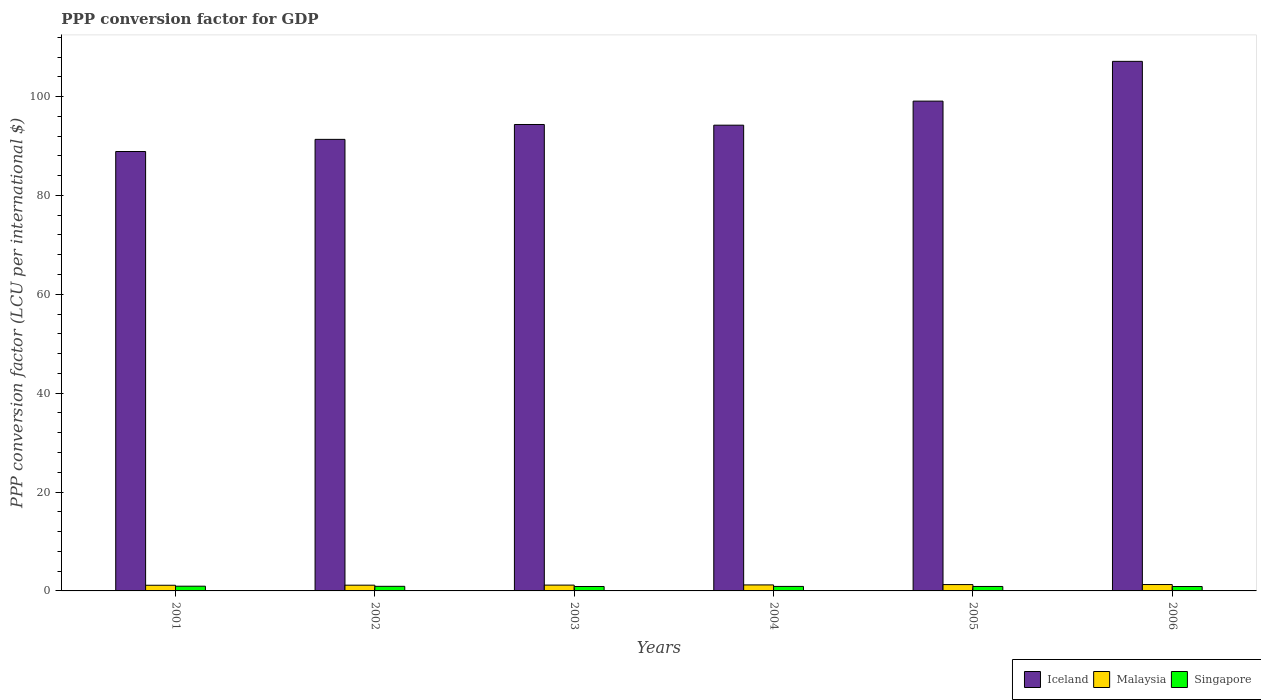How many different coloured bars are there?
Your answer should be very brief. 3. How many groups of bars are there?
Provide a succinct answer. 6. Are the number of bars per tick equal to the number of legend labels?
Ensure brevity in your answer.  Yes. How many bars are there on the 1st tick from the left?
Provide a short and direct response. 3. How many bars are there on the 3rd tick from the right?
Offer a terse response. 3. What is the label of the 6th group of bars from the left?
Make the answer very short. 2006. In how many cases, is the number of bars for a given year not equal to the number of legend labels?
Ensure brevity in your answer.  0. What is the PPP conversion factor for GDP in Iceland in 2002?
Ensure brevity in your answer.  91.34. Across all years, what is the maximum PPP conversion factor for GDP in Malaysia?
Your answer should be very brief. 1.29. Across all years, what is the minimum PPP conversion factor for GDP in Singapore?
Your response must be concise. 0.89. In which year was the PPP conversion factor for GDP in Iceland minimum?
Give a very brief answer. 2001. What is the total PPP conversion factor for GDP in Iceland in the graph?
Provide a short and direct response. 574.99. What is the difference between the PPP conversion factor for GDP in Malaysia in 2001 and that in 2006?
Your response must be concise. -0.15. What is the difference between the PPP conversion factor for GDP in Singapore in 2005 and the PPP conversion factor for GDP in Iceland in 2004?
Give a very brief answer. -93.31. What is the average PPP conversion factor for GDP in Iceland per year?
Make the answer very short. 95.83. In the year 2001, what is the difference between the PPP conversion factor for GDP in Malaysia and PPP conversion factor for GDP in Iceland?
Your response must be concise. -87.74. What is the ratio of the PPP conversion factor for GDP in Iceland in 2003 to that in 2005?
Your answer should be compact. 0.95. Is the difference between the PPP conversion factor for GDP in Malaysia in 2005 and 2006 greater than the difference between the PPP conversion factor for GDP in Iceland in 2005 and 2006?
Offer a very short reply. Yes. What is the difference between the highest and the second highest PPP conversion factor for GDP in Iceland?
Keep it short and to the point. 8.04. What is the difference between the highest and the lowest PPP conversion factor for GDP in Singapore?
Provide a short and direct response. 0.07. In how many years, is the PPP conversion factor for GDP in Iceland greater than the average PPP conversion factor for GDP in Iceland taken over all years?
Make the answer very short. 2. Is the sum of the PPP conversion factor for GDP in Malaysia in 2004 and 2006 greater than the maximum PPP conversion factor for GDP in Singapore across all years?
Make the answer very short. Yes. What does the 2nd bar from the left in 2003 represents?
Provide a short and direct response. Malaysia. What does the 3rd bar from the right in 2003 represents?
Keep it short and to the point. Iceland. Does the graph contain any zero values?
Offer a terse response. No. Does the graph contain grids?
Ensure brevity in your answer.  No. Where does the legend appear in the graph?
Offer a terse response. Bottom right. What is the title of the graph?
Make the answer very short. PPP conversion factor for GDP. What is the label or title of the Y-axis?
Make the answer very short. PPP conversion factor (LCU per international $). What is the PPP conversion factor (LCU per international $) of Iceland in 2001?
Offer a very short reply. 88.89. What is the PPP conversion factor (LCU per international $) in Malaysia in 2001?
Your answer should be very brief. 1.14. What is the PPP conversion factor (LCU per international $) of Singapore in 2001?
Your answer should be compact. 0.96. What is the PPP conversion factor (LCU per international $) in Iceland in 2002?
Make the answer very short. 91.34. What is the PPP conversion factor (LCU per international $) of Malaysia in 2002?
Offer a very short reply. 1.16. What is the PPP conversion factor (LCU per international $) of Singapore in 2002?
Your response must be concise. 0.93. What is the PPP conversion factor (LCU per international $) of Iceland in 2003?
Offer a terse response. 94.35. What is the PPP conversion factor (LCU per international $) in Malaysia in 2003?
Provide a short and direct response. 1.18. What is the PPP conversion factor (LCU per international $) in Singapore in 2003?
Give a very brief answer. 0.9. What is the PPP conversion factor (LCU per international $) in Iceland in 2004?
Offer a terse response. 94.21. What is the PPP conversion factor (LCU per international $) of Malaysia in 2004?
Make the answer very short. 1.21. What is the PPP conversion factor (LCU per international $) of Singapore in 2004?
Ensure brevity in your answer.  0.91. What is the PPP conversion factor (LCU per international $) in Iceland in 2005?
Provide a succinct answer. 99.08. What is the PPP conversion factor (LCU per international $) in Malaysia in 2005?
Keep it short and to the point. 1.28. What is the PPP conversion factor (LCU per international $) in Singapore in 2005?
Your answer should be compact. 0.9. What is the PPP conversion factor (LCU per international $) of Iceland in 2006?
Offer a terse response. 107.12. What is the PPP conversion factor (LCU per international $) in Malaysia in 2006?
Provide a succinct answer. 1.29. What is the PPP conversion factor (LCU per international $) of Singapore in 2006?
Make the answer very short. 0.89. Across all years, what is the maximum PPP conversion factor (LCU per international $) in Iceland?
Your answer should be compact. 107.12. Across all years, what is the maximum PPP conversion factor (LCU per international $) in Malaysia?
Your response must be concise. 1.29. Across all years, what is the maximum PPP conversion factor (LCU per international $) in Singapore?
Provide a succinct answer. 0.96. Across all years, what is the minimum PPP conversion factor (LCU per international $) of Iceland?
Your answer should be compact. 88.89. Across all years, what is the minimum PPP conversion factor (LCU per international $) of Malaysia?
Your answer should be very brief. 1.14. Across all years, what is the minimum PPP conversion factor (LCU per international $) of Singapore?
Offer a terse response. 0.89. What is the total PPP conversion factor (LCU per international $) in Iceland in the graph?
Give a very brief answer. 574.99. What is the total PPP conversion factor (LCU per international $) of Malaysia in the graph?
Provide a short and direct response. 7.27. What is the total PPP conversion factor (LCU per international $) of Singapore in the graph?
Ensure brevity in your answer.  5.49. What is the difference between the PPP conversion factor (LCU per international $) in Iceland in 2001 and that in 2002?
Keep it short and to the point. -2.46. What is the difference between the PPP conversion factor (LCU per international $) in Malaysia in 2001 and that in 2002?
Provide a succinct answer. -0.02. What is the difference between the PPP conversion factor (LCU per international $) in Singapore in 2001 and that in 2002?
Offer a very short reply. 0.03. What is the difference between the PPP conversion factor (LCU per international $) in Iceland in 2001 and that in 2003?
Ensure brevity in your answer.  -5.47. What is the difference between the PPP conversion factor (LCU per international $) of Malaysia in 2001 and that in 2003?
Provide a short and direct response. -0.03. What is the difference between the PPP conversion factor (LCU per international $) in Iceland in 2001 and that in 2004?
Your response must be concise. -5.33. What is the difference between the PPP conversion factor (LCU per international $) in Malaysia in 2001 and that in 2004?
Ensure brevity in your answer.  -0.07. What is the difference between the PPP conversion factor (LCU per international $) of Singapore in 2001 and that in 2004?
Offer a terse response. 0.05. What is the difference between the PPP conversion factor (LCU per international $) in Iceland in 2001 and that in 2005?
Give a very brief answer. -10.19. What is the difference between the PPP conversion factor (LCU per international $) of Malaysia in 2001 and that in 2005?
Your answer should be very brief. -0.14. What is the difference between the PPP conversion factor (LCU per international $) in Singapore in 2001 and that in 2005?
Give a very brief answer. 0.06. What is the difference between the PPP conversion factor (LCU per international $) in Iceland in 2001 and that in 2006?
Your response must be concise. -18.24. What is the difference between the PPP conversion factor (LCU per international $) in Malaysia in 2001 and that in 2006?
Provide a short and direct response. -0.15. What is the difference between the PPP conversion factor (LCU per international $) in Singapore in 2001 and that in 2006?
Provide a short and direct response. 0.07. What is the difference between the PPP conversion factor (LCU per international $) in Iceland in 2002 and that in 2003?
Your answer should be compact. -3.01. What is the difference between the PPP conversion factor (LCU per international $) of Malaysia in 2002 and that in 2003?
Offer a terse response. -0.01. What is the difference between the PPP conversion factor (LCU per international $) of Singapore in 2002 and that in 2003?
Offer a terse response. 0.03. What is the difference between the PPP conversion factor (LCU per international $) in Iceland in 2002 and that in 2004?
Your answer should be very brief. -2.87. What is the difference between the PPP conversion factor (LCU per international $) of Malaysia in 2002 and that in 2004?
Provide a succinct answer. -0.05. What is the difference between the PPP conversion factor (LCU per international $) of Singapore in 2002 and that in 2004?
Your response must be concise. 0.02. What is the difference between the PPP conversion factor (LCU per international $) of Iceland in 2002 and that in 2005?
Your answer should be compact. -7.74. What is the difference between the PPP conversion factor (LCU per international $) in Malaysia in 2002 and that in 2005?
Ensure brevity in your answer.  -0.12. What is the difference between the PPP conversion factor (LCU per international $) in Singapore in 2002 and that in 2005?
Provide a short and direct response. 0.03. What is the difference between the PPP conversion factor (LCU per international $) in Iceland in 2002 and that in 2006?
Your response must be concise. -15.78. What is the difference between the PPP conversion factor (LCU per international $) in Malaysia in 2002 and that in 2006?
Offer a very short reply. -0.13. What is the difference between the PPP conversion factor (LCU per international $) in Singapore in 2002 and that in 2006?
Ensure brevity in your answer.  0.04. What is the difference between the PPP conversion factor (LCU per international $) of Iceland in 2003 and that in 2004?
Ensure brevity in your answer.  0.14. What is the difference between the PPP conversion factor (LCU per international $) of Malaysia in 2003 and that in 2004?
Ensure brevity in your answer.  -0.04. What is the difference between the PPP conversion factor (LCU per international $) in Singapore in 2003 and that in 2004?
Your answer should be compact. -0.01. What is the difference between the PPP conversion factor (LCU per international $) of Iceland in 2003 and that in 2005?
Keep it short and to the point. -4.73. What is the difference between the PPP conversion factor (LCU per international $) in Malaysia in 2003 and that in 2005?
Your answer should be very brief. -0.1. What is the difference between the PPP conversion factor (LCU per international $) in Singapore in 2003 and that in 2005?
Your answer should be compact. -0. What is the difference between the PPP conversion factor (LCU per international $) of Iceland in 2003 and that in 2006?
Provide a succinct answer. -12.77. What is the difference between the PPP conversion factor (LCU per international $) in Malaysia in 2003 and that in 2006?
Give a very brief answer. -0.12. What is the difference between the PPP conversion factor (LCU per international $) of Singapore in 2003 and that in 2006?
Offer a very short reply. 0.01. What is the difference between the PPP conversion factor (LCU per international $) in Iceland in 2004 and that in 2005?
Offer a very short reply. -4.87. What is the difference between the PPP conversion factor (LCU per international $) of Malaysia in 2004 and that in 2005?
Your answer should be very brief. -0.07. What is the difference between the PPP conversion factor (LCU per international $) in Singapore in 2004 and that in 2005?
Your answer should be very brief. 0.01. What is the difference between the PPP conversion factor (LCU per international $) in Iceland in 2004 and that in 2006?
Offer a terse response. -12.91. What is the difference between the PPP conversion factor (LCU per international $) in Malaysia in 2004 and that in 2006?
Ensure brevity in your answer.  -0.08. What is the difference between the PPP conversion factor (LCU per international $) of Singapore in 2004 and that in 2006?
Offer a terse response. 0.02. What is the difference between the PPP conversion factor (LCU per international $) of Iceland in 2005 and that in 2006?
Provide a short and direct response. -8.04. What is the difference between the PPP conversion factor (LCU per international $) of Malaysia in 2005 and that in 2006?
Your answer should be very brief. -0.01. What is the difference between the PPP conversion factor (LCU per international $) of Singapore in 2005 and that in 2006?
Provide a succinct answer. 0.01. What is the difference between the PPP conversion factor (LCU per international $) of Iceland in 2001 and the PPP conversion factor (LCU per international $) of Malaysia in 2002?
Give a very brief answer. 87.72. What is the difference between the PPP conversion factor (LCU per international $) in Iceland in 2001 and the PPP conversion factor (LCU per international $) in Singapore in 2002?
Your answer should be compact. 87.95. What is the difference between the PPP conversion factor (LCU per international $) in Malaysia in 2001 and the PPP conversion factor (LCU per international $) in Singapore in 2002?
Provide a short and direct response. 0.21. What is the difference between the PPP conversion factor (LCU per international $) in Iceland in 2001 and the PPP conversion factor (LCU per international $) in Malaysia in 2003?
Your answer should be very brief. 87.71. What is the difference between the PPP conversion factor (LCU per international $) of Iceland in 2001 and the PPP conversion factor (LCU per international $) of Singapore in 2003?
Give a very brief answer. 87.99. What is the difference between the PPP conversion factor (LCU per international $) in Malaysia in 2001 and the PPP conversion factor (LCU per international $) in Singapore in 2003?
Make the answer very short. 0.25. What is the difference between the PPP conversion factor (LCU per international $) in Iceland in 2001 and the PPP conversion factor (LCU per international $) in Malaysia in 2004?
Provide a short and direct response. 87.67. What is the difference between the PPP conversion factor (LCU per international $) in Iceland in 2001 and the PPP conversion factor (LCU per international $) in Singapore in 2004?
Provide a short and direct response. 87.97. What is the difference between the PPP conversion factor (LCU per international $) in Malaysia in 2001 and the PPP conversion factor (LCU per international $) in Singapore in 2004?
Provide a short and direct response. 0.23. What is the difference between the PPP conversion factor (LCU per international $) of Iceland in 2001 and the PPP conversion factor (LCU per international $) of Malaysia in 2005?
Offer a terse response. 87.6. What is the difference between the PPP conversion factor (LCU per international $) of Iceland in 2001 and the PPP conversion factor (LCU per international $) of Singapore in 2005?
Offer a terse response. 87.98. What is the difference between the PPP conversion factor (LCU per international $) of Malaysia in 2001 and the PPP conversion factor (LCU per international $) of Singapore in 2005?
Ensure brevity in your answer.  0.24. What is the difference between the PPP conversion factor (LCU per international $) of Iceland in 2001 and the PPP conversion factor (LCU per international $) of Malaysia in 2006?
Your answer should be very brief. 87.59. What is the difference between the PPP conversion factor (LCU per international $) of Iceland in 2001 and the PPP conversion factor (LCU per international $) of Singapore in 2006?
Keep it short and to the point. 88. What is the difference between the PPP conversion factor (LCU per international $) in Malaysia in 2001 and the PPP conversion factor (LCU per international $) in Singapore in 2006?
Offer a terse response. 0.25. What is the difference between the PPP conversion factor (LCU per international $) of Iceland in 2002 and the PPP conversion factor (LCU per international $) of Malaysia in 2003?
Give a very brief answer. 90.16. What is the difference between the PPP conversion factor (LCU per international $) of Iceland in 2002 and the PPP conversion factor (LCU per international $) of Singapore in 2003?
Keep it short and to the point. 90.44. What is the difference between the PPP conversion factor (LCU per international $) of Malaysia in 2002 and the PPP conversion factor (LCU per international $) of Singapore in 2003?
Your answer should be very brief. 0.26. What is the difference between the PPP conversion factor (LCU per international $) of Iceland in 2002 and the PPP conversion factor (LCU per international $) of Malaysia in 2004?
Give a very brief answer. 90.13. What is the difference between the PPP conversion factor (LCU per international $) of Iceland in 2002 and the PPP conversion factor (LCU per international $) of Singapore in 2004?
Offer a terse response. 90.43. What is the difference between the PPP conversion factor (LCU per international $) of Malaysia in 2002 and the PPP conversion factor (LCU per international $) of Singapore in 2004?
Give a very brief answer. 0.25. What is the difference between the PPP conversion factor (LCU per international $) of Iceland in 2002 and the PPP conversion factor (LCU per international $) of Malaysia in 2005?
Provide a short and direct response. 90.06. What is the difference between the PPP conversion factor (LCU per international $) of Iceland in 2002 and the PPP conversion factor (LCU per international $) of Singapore in 2005?
Provide a succinct answer. 90.44. What is the difference between the PPP conversion factor (LCU per international $) in Malaysia in 2002 and the PPP conversion factor (LCU per international $) in Singapore in 2005?
Ensure brevity in your answer.  0.26. What is the difference between the PPP conversion factor (LCU per international $) of Iceland in 2002 and the PPP conversion factor (LCU per international $) of Malaysia in 2006?
Make the answer very short. 90.05. What is the difference between the PPP conversion factor (LCU per international $) of Iceland in 2002 and the PPP conversion factor (LCU per international $) of Singapore in 2006?
Provide a succinct answer. 90.45. What is the difference between the PPP conversion factor (LCU per international $) of Malaysia in 2002 and the PPP conversion factor (LCU per international $) of Singapore in 2006?
Make the answer very short. 0.27. What is the difference between the PPP conversion factor (LCU per international $) in Iceland in 2003 and the PPP conversion factor (LCU per international $) in Malaysia in 2004?
Give a very brief answer. 93.14. What is the difference between the PPP conversion factor (LCU per international $) of Iceland in 2003 and the PPP conversion factor (LCU per international $) of Singapore in 2004?
Give a very brief answer. 93.44. What is the difference between the PPP conversion factor (LCU per international $) in Malaysia in 2003 and the PPP conversion factor (LCU per international $) in Singapore in 2004?
Offer a very short reply. 0.27. What is the difference between the PPP conversion factor (LCU per international $) of Iceland in 2003 and the PPP conversion factor (LCU per international $) of Malaysia in 2005?
Provide a succinct answer. 93.07. What is the difference between the PPP conversion factor (LCU per international $) of Iceland in 2003 and the PPP conversion factor (LCU per international $) of Singapore in 2005?
Keep it short and to the point. 93.45. What is the difference between the PPP conversion factor (LCU per international $) of Malaysia in 2003 and the PPP conversion factor (LCU per international $) of Singapore in 2005?
Provide a short and direct response. 0.28. What is the difference between the PPP conversion factor (LCU per international $) of Iceland in 2003 and the PPP conversion factor (LCU per international $) of Malaysia in 2006?
Make the answer very short. 93.06. What is the difference between the PPP conversion factor (LCU per international $) of Iceland in 2003 and the PPP conversion factor (LCU per international $) of Singapore in 2006?
Offer a very short reply. 93.46. What is the difference between the PPP conversion factor (LCU per international $) in Malaysia in 2003 and the PPP conversion factor (LCU per international $) in Singapore in 2006?
Give a very brief answer. 0.29. What is the difference between the PPP conversion factor (LCU per international $) of Iceland in 2004 and the PPP conversion factor (LCU per international $) of Malaysia in 2005?
Provide a succinct answer. 92.93. What is the difference between the PPP conversion factor (LCU per international $) in Iceland in 2004 and the PPP conversion factor (LCU per international $) in Singapore in 2005?
Ensure brevity in your answer.  93.31. What is the difference between the PPP conversion factor (LCU per international $) in Malaysia in 2004 and the PPP conversion factor (LCU per international $) in Singapore in 2005?
Your response must be concise. 0.31. What is the difference between the PPP conversion factor (LCU per international $) of Iceland in 2004 and the PPP conversion factor (LCU per international $) of Malaysia in 2006?
Offer a terse response. 92.92. What is the difference between the PPP conversion factor (LCU per international $) in Iceland in 2004 and the PPP conversion factor (LCU per international $) in Singapore in 2006?
Provide a short and direct response. 93.32. What is the difference between the PPP conversion factor (LCU per international $) of Malaysia in 2004 and the PPP conversion factor (LCU per international $) of Singapore in 2006?
Your answer should be very brief. 0.32. What is the difference between the PPP conversion factor (LCU per international $) in Iceland in 2005 and the PPP conversion factor (LCU per international $) in Malaysia in 2006?
Your answer should be very brief. 97.79. What is the difference between the PPP conversion factor (LCU per international $) in Iceland in 2005 and the PPP conversion factor (LCU per international $) in Singapore in 2006?
Make the answer very short. 98.19. What is the difference between the PPP conversion factor (LCU per international $) of Malaysia in 2005 and the PPP conversion factor (LCU per international $) of Singapore in 2006?
Your response must be concise. 0.39. What is the average PPP conversion factor (LCU per international $) of Iceland per year?
Keep it short and to the point. 95.83. What is the average PPP conversion factor (LCU per international $) of Malaysia per year?
Provide a succinct answer. 1.21. What is the average PPP conversion factor (LCU per international $) in Singapore per year?
Offer a terse response. 0.91. In the year 2001, what is the difference between the PPP conversion factor (LCU per international $) of Iceland and PPP conversion factor (LCU per international $) of Malaysia?
Offer a terse response. 87.74. In the year 2001, what is the difference between the PPP conversion factor (LCU per international $) in Iceland and PPP conversion factor (LCU per international $) in Singapore?
Provide a short and direct response. 87.93. In the year 2001, what is the difference between the PPP conversion factor (LCU per international $) of Malaysia and PPP conversion factor (LCU per international $) of Singapore?
Provide a succinct answer. 0.19. In the year 2002, what is the difference between the PPP conversion factor (LCU per international $) in Iceland and PPP conversion factor (LCU per international $) in Malaysia?
Give a very brief answer. 90.18. In the year 2002, what is the difference between the PPP conversion factor (LCU per international $) in Iceland and PPP conversion factor (LCU per international $) in Singapore?
Keep it short and to the point. 90.41. In the year 2002, what is the difference between the PPP conversion factor (LCU per international $) in Malaysia and PPP conversion factor (LCU per international $) in Singapore?
Ensure brevity in your answer.  0.23. In the year 2003, what is the difference between the PPP conversion factor (LCU per international $) of Iceland and PPP conversion factor (LCU per international $) of Malaysia?
Make the answer very short. 93.17. In the year 2003, what is the difference between the PPP conversion factor (LCU per international $) in Iceland and PPP conversion factor (LCU per international $) in Singapore?
Ensure brevity in your answer.  93.45. In the year 2003, what is the difference between the PPP conversion factor (LCU per international $) in Malaysia and PPP conversion factor (LCU per international $) in Singapore?
Make the answer very short. 0.28. In the year 2004, what is the difference between the PPP conversion factor (LCU per international $) of Iceland and PPP conversion factor (LCU per international $) of Malaysia?
Ensure brevity in your answer.  93. In the year 2004, what is the difference between the PPP conversion factor (LCU per international $) in Iceland and PPP conversion factor (LCU per international $) in Singapore?
Your answer should be compact. 93.3. In the year 2004, what is the difference between the PPP conversion factor (LCU per international $) in Malaysia and PPP conversion factor (LCU per international $) in Singapore?
Your answer should be very brief. 0.3. In the year 2005, what is the difference between the PPP conversion factor (LCU per international $) of Iceland and PPP conversion factor (LCU per international $) of Malaysia?
Your answer should be very brief. 97.8. In the year 2005, what is the difference between the PPP conversion factor (LCU per international $) of Iceland and PPP conversion factor (LCU per international $) of Singapore?
Your answer should be very brief. 98.18. In the year 2005, what is the difference between the PPP conversion factor (LCU per international $) in Malaysia and PPP conversion factor (LCU per international $) in Singapore?
Ensure brevity in your answer.  0.38. In the year 2006, what is the difference between the PPP conversion factor (LCU per international $) of Iceland and PPP conversion factor (LCU per international $) of Malaysia?
Keep it short and to the point. 105.83. In the year 2006, what is the difference between the PPP conversion factor (LCU per international $) in Iceland and PPP conversion factor (LCU per international $) in Singapore?
Make the answer very short. 106.23. In the year 2006, what is the difference between the PPP conversion factor (LCU per international $) of Malaysia and PPP conversion factor (LCU per international $) of Singapore?
Make the answer very short. 0.4. What is the ratio of the PPP conversion factor (LCU per international $) in Iceland in 2001 to that in 2002?
Provide a succinct answer. 0.97. What is the ratio of the PPP conversion factor (LCU per international $) of Malaysia in 2001 to that in 2002?
Provide a succinct answer. 0.98. What is the ratio of the PPP conversion factor (LCU per international $) in Singapore in 2001 to that in 2002?
Your answer should be compact. 1.03. What is the ratio of the PPP conversion factor (LCU per international $) in Iceland in 2001 to that in 2003?
Keep it short and to the point. 0.94. What is the ratio of the PPP conversion factor (LCU per international $) of Malaysia in 2001 to that in 2003?
Your answer should be very brief. 0.97. What is the ratio of the PPP conversion factor (LCU per international $) of Singapore in 2001 to that in 2003?
Your answer should be compact. 1.07. What is the ratio of the PPP conversion factor (LCU per international $) of Iceland in 2001 to that in 2004?
Your response must be concise. 0.94. What is the ratio of the PPP conversion factor (LCU per international $) in Malaysia in 2001 to that in 2004?
Your answer should be compact. 0.94. What is the ratio of the PPP conversion factor (LCU per international $) of Singapore in 2001 to that in 2004?
Your answer should be very brief. 1.05. What is the ratio of the PPP conversion factor (LCU per international $) in Iceland in 2001 to that in 2005?
Provide a short and direct response. 0.9. What is the ratio of the PPP conversion factor (LCU per international $) in Malaysia in 2001 to that in 2005?
Give a very brief answer. 0.89. What is the ratio of the PPP conversion factor (LCU per international $) of Singapore in 2001 to that in 2005?
Ensure brevity in your answer.  1.06. What is the ratio of the PPP conversion factor (LCU per international $) of Iceland in 2001 to that in 2006?
Provide a short and direct response. 0.83. What is the ratio of the PPP conversion factor (LCU per international $) in Malaysia in 2001 to that in 2006?
Ensure brevity in your answer.  0.89. What is the ratio of the PPP conversion factor (LCU per international $) of Singapore in 2001 to that in 2006?
Make the answer very short. 1.08. What is the ratio of the PPP conversion factor (LCU per international $) of Iceland in 2002 to that in 2003?
Offer a very short reply. 0.97. What is the ratio of the PPP conversion factor (LCU per international $) in Malaysia in 2002 to that in 2003?
Offer a terse response. 0.99. What is the ratio of the PPP conversion factor (LCU per international $) in Singapore in 2002 to that in 2003?
Your answer should be very brief. 1.04. What is the ratio of the PPP conversion factor (LCU per international $) of Iceland in 2002 to that in 2004?
Give a very brief answer. 0.97. What is the ratio of the PPP conversion factor (LCU per international $) of Singapore in 2002 to that in 2004?
Make the answer very short. 1.02. What is the ratio of the PPP conversion factor (LCU per international $) in Iceland in 2002 to that in 2005?
Provide a succinct answer. 0.92. What is the ratio of the PPP conversion factor (LCU per international $) in Malaysia in 2002 to that in 2005?
Ensure brevity in your answer.  0.91. What is the ratio of the PPP conversion factor (LCU per international $) of Singapore in 2002 to that in 2005?
Offer a terse response. 1.03. What is the ratio of the PPP conversion factor (LCU per international $) in Iceland in 2002 to that in 2006?
Ensure brevity in your answer.  0.85. What is the ratio of the PPP conversion factor (LCU per international $) in Malaysia in 2002 to that in 2006?
Give a very brief answer. 0.9. What is the ratio of the PPP conversion factor (LCU per international $) in Singapore in 2002 to that in 2006?
Ensure brevity in your answer.  1.05. What is the ratio of the PPP conversion factor (LCU per international $) in Iceland in 2003 to that in 2004?
Provide a short and direct response. 1. What is the ratio of the PPP conversion factor (LCU per international $) of Malaysia in 2003 to that in 2004?
Make the answer very short. 0.97. What is the ratio of the PPP conversion factor (LCU per international $) of Singapore in 2003 to that in 2004?
Provide a succinct answer. 0.99. What is the ratio of the PPP conversion factor (LCU per international $) of Iceland in 2003 to that in 2005?
Offer a very short reply. 0.95. What is the ratio of the PPP conversion factor (LCU per international $) in Malaysia in 2003 to that in 2005?
Keep it short and to the point. 0.92. What is the ratio of the PPP conversion factor (LCU per international $) in Iceland in 2003 to that in 2006?
Provide a short and direct response. 0.88. What is the ratio of the PPP conversion factor (LCU per international $) of Malaysia in 2003 to that in 2006?
Your answer should be compact. 0.91. What is the ratio of the PPP conversion factor (LCU per international $) in Singapore in 2003 to that in 2006?
Your response must be concise. 1.01. What is the ratio of the PPP conversion factor (LCU per international $) in Iceland in 2004 to that in 2005?
Give a very brief answer. 0.95. What is the ratio of the PPP conversion factor (LCU per international $) in Malaysia in 2004 to that in 2005?
Ensure brevity in your answer.  0.95. What is the ratio of the PPP conversion factor (LCU per international $) of Singapore in 2004 to that in 2005?
Give a very brief answer. 1.01. What is the ratio of the PPP conversion factor (LCU per international $) of Iceland in 2004 to that in 2006?
Offer a terse response. 0.88. What is the ratio of the PPP conversion factor (LCU per international $) of Malaysia in 2004 to that in 2006?
Keep it short and to the point. 0.94. What is the ratio of the PPP conversion factor (LCU per international $) in Singapore in 2004 to that in 2006?
Make the answer very short. 1.02. What is the ratio of the PPP conversion factor (LCU per international $) in Iceland in 2005 to that in 2006?
Your response must be concise. 0.92. What is the ratio of the PPP conversion factor (LCU per international $) of Singapore in 2005 to that in 2006?
Provide a short and direct response. 1.01. What is the difference between the highest and the second highest PPP conversion factor (LCU per international $) in Iceland?
Provide a short and direct response. 8.04. What is the difference between the highest and the second highest PPP conversion factor (LCU per international $) in Malaysia?
Provide a short and direct response. 0.01. What is the difference between the highest and the second highest PPP conversion factor (LCU per international $) in Singapore?
Your response must be concise. 0.03. What is the difference between the highest and the lowest PPP conversion factor (LCU per international $) in Iceland?
Ensure brevity in your answer.  18.24. What is the difference between the highest and the lowest PPP conversion factor (LCU per international $) in Malaysia?
Your response must be concise. 0.15. What is the difference between the highest and the lowest PPP conversion factor (LCU per international $) of Singapore?
Provide a short and direct response. 0.07. 